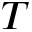<formula> <loc_0><loc_0><loc_500><loc_500>T</formula> 